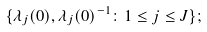Convert formula to latex. <formula><loc_0><loc_0><loc_500><loc_500>\{ \lambda _ { j } ( 0 ) , \lambda _ { j } ( 0 ) ^ { - 1 } \colon 1 \leq j \leq J \} ;</formula> 